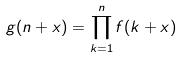<formula> <loc_0><loc_0><loc_500><loc_500>g ( n + x ) = \prod _ { k = 1 } ^ { n } f ( k + x )</formula> 